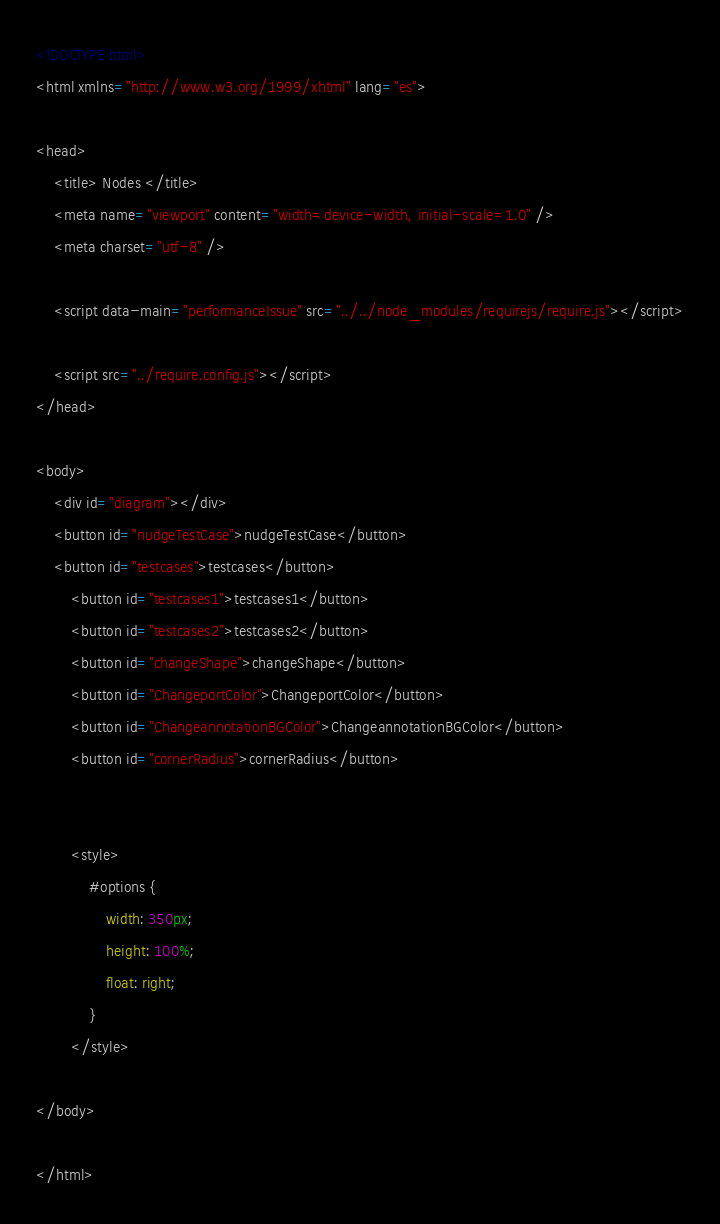<code> <loc_0><loc_0><loc_500><loc_500><_HTML_><!DOCTYPE html>
<html xmlns="http://www.w3.org/1999/xhtml" lang="es">

<head>
    <title> Nodes </title>
    <meta name="viewport" content="width=device-width, initial-scale=1.0" />
    <meta charset="utf-8" />

    <script data-main="performanceIssue" src="../../node_modules/requirejs/require.js"></script>

    <script src="../require.config.js"></script>
</head>

<body>
    <div id="diagram"></div>
    <button id="nudgeTestCase">nudgeTestCase</button>
    <button id="testcases">testcases</button>
        <button id="testcases1">testcases1</button>
        <button id="testcases2">testcases2</button>
        <button id="changeShape">changeShape</button>
        <button id="ChangeportColor">ChangeportColor</button>
        <button id="ChangeannotationBGColor">ChangeannotationBGColor</button>
        <button id="cornerRadius">cornerRadius</button>


        <style>
            #options {
                width: 350px;
                height: 100%;
                float: right;
            }
        </style>

</body>

</html></code> 